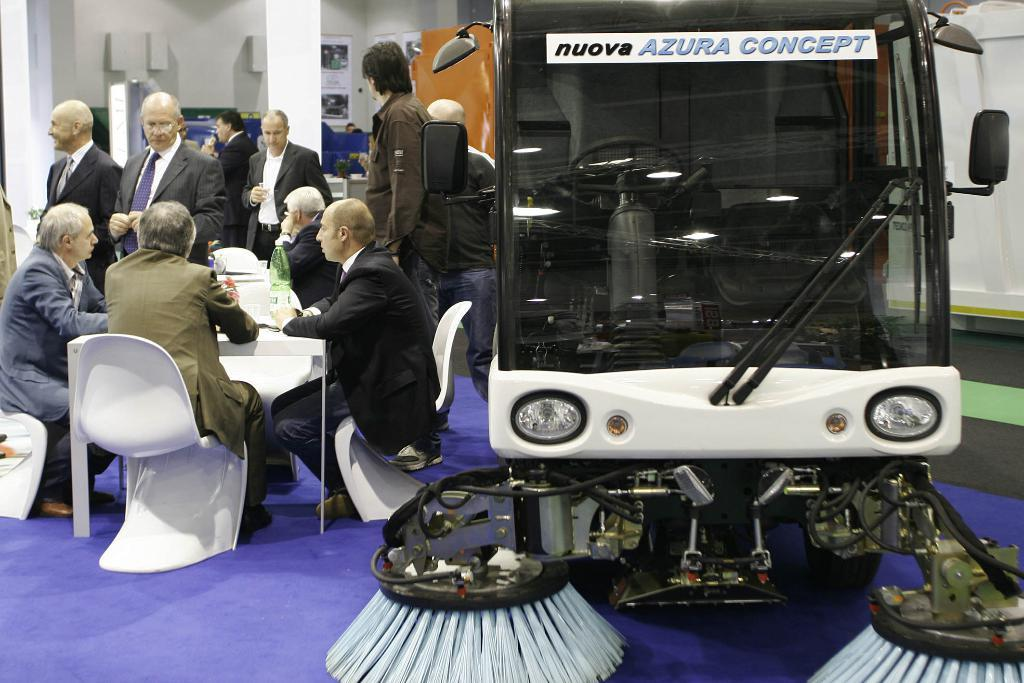What are the persons in the image doing? The persons in the image are sitting on chairs. Can you describe the vehicle on the right side of the image? There is a sweeping vehicle on the right side of the image. What type of trail can be seen behind the persons in the image? There is no trail visible behind the persons in the image. What kind of pain is being experienced by the persons in the image? There is no indication of pain being experienced by the persons in the image. 